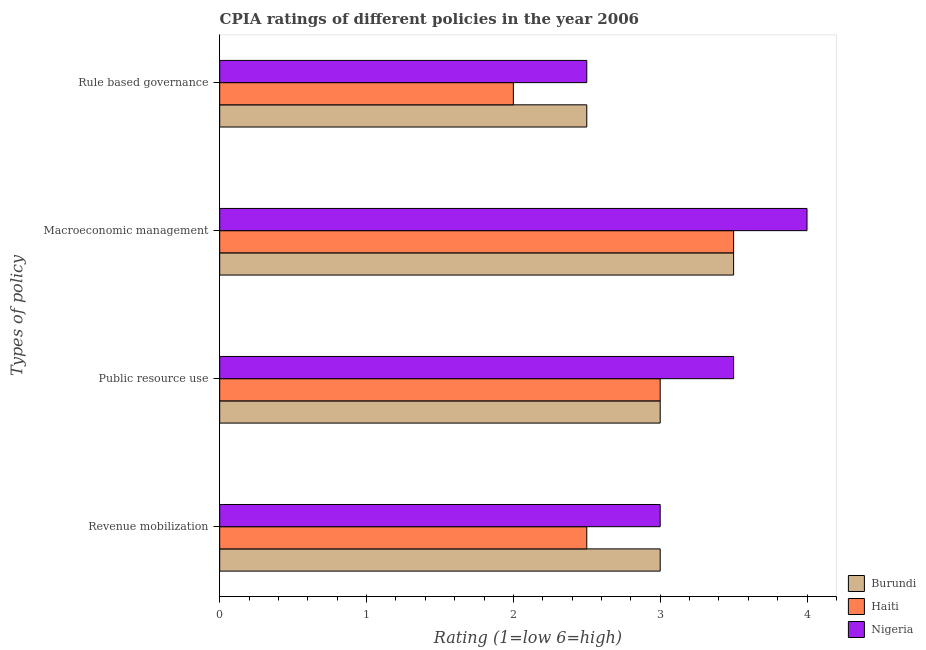How many groups of bars are there?
Provide a succinct answer. 4. How many bars are there on the 4th tick from the top?
Keep it short and to the point. 3. What is the label of the 4th group of bars from the top?
Your response must be concise. Revenue mobilization. Across all countries, what is the minimum cpia rating of macroeconomic management?
Keep it short and to the point. 3.5. In which country was the cpia rating of macroeconomic management maximum?
Offer a terse response. Nigeria. In which country was the cpia rating of macroeconomic management minimum?
Your answer should be compact. Burundi. What is the difference between the cpia rating of public resource use in Haiti and that in Burundi?
Your answer should be compact. 0. What is the difference between the cpia rating of rule based governance in Burundi and the cpia rating of public resource use in Nigeria?
Offer a very short reply. -1. What is the average cpia rating of macroeconomic management per country?
Offer a terse response. 3.67. In how many countries, is the cpia rating of rule based governance greater than 2.8 ?
Offer a terse response. 0. What is the ratio of the cpia rating of public resource use in Burundi to that in Haiti?
Your answer should be very brief. 1. Is the cpia rating of revenue mobilization in Burundi less than that in Nigeria?
Your response must be concise. No. What is the difference between the highest and the second highest cpia rating of public resource use?
Provide a short and direct response. 0.5. What is the difference between the highest and the lowest cpia rating of revenue mobilization?
Make the answer very short. 0.5. In how many countries, is the cpia rating of public resource use greater than the average cpia rating of public resource use taken over all countries?
Offer a terse response. 1. Is it the case that in every country, the sum of the cpia rating of public resource use and cpia rating of rule based governance is greater than the sum of cpia rating of macroeconomic management and cpia rating of revenue mobilization?
Keep it short and to the point. No. What does the 2nd bar from the top in Macroeconomic management represents?
Your answer should be compact. Haiti. What does the 3rd bar from the bottom in Macroeconomic management represents?
Provide a short and direct response. Nigeria. Is it the case that in every country, the sum of the cpia rating of revenue mobilization and cpia rating of public resource use is greater than the cpia rating of macroeconomic management?
Offer a terse response. Yes. Are all the bars in the graph horizontal?
Give a very brief answer. Yes. How many countries are there in the graph?
Provide a short and direct response. 3. Does the graph contain grids?
Your answer should be very brief. No. Where does the legend appear in the graph?
Ensure brevity in your answer.  Bottom right. How are the legend labels stacked?
Provide a short and direct response. Vertical. What is the title of the graph?
Keep it short and to the point. CPIA ratings of different policies in the year 2006. Does "Haiti" appear as one of the legend labels in the graph?
Make the answer very short. Yes. What is the label or title of the X-axis?
Your answer should be compact. Rating (1=low 6=high). What is the label or title of the Y-axis?
Keep it short and to the point. Types of policy. What is the Rating (1=low 6=high) in Burundi in Revenue mobilization?
Give a very brief answer. 3. What is the Rating (1=low 6=high) of Nigeria in Revenue mobilization?
Give a very brief answer. 3. What is the Rating (1=low 6=high) in Burundi in Public resource use?
Give a very brief answer. 3. What is the Rating (1=low 6=high) in Haiti in Public resource use?
Offer a terse response. 3. What is the Rating (1=low 6=high) in Haiti in Rule based governance?
Give a very brief answer. 2. What is the Rating (1=low 6=high) in Nigeria in Rule based governance?
Make the answer very short. 2.5. Across all Types of policy, what is the maximum Rating (1=low 6=high) of Burundi?
Keep it short and to the point. 3.5. Across all Types of policy, what is the maximum Rating (1=low 6=high) in Haiti?
Your answer should be compact. 3.5. Across all Types of policy, what is the maximum Rating (1=low 6=high) in Nigeria?
Your answer should be compact. 4. Across all Types of policy, what is the minimum Rating (1=low 6=high) in Haiti?
Your answer should be compact. 2. What is the total Rating (1=low 6=high) in Haiti in the graph?
Keep it short and to the point. 11. What is the difference between the Rating (1=low 6=high) in Nigeria in Revenue mobilization and that in Macroeconomic management?
Provide a short and direct response. -1. What is the difference between the Rating (1=low 6=high) in Haiti in Revenue mobilization and that in Rule based governance?
Provide a succinct answer. 0.5. What is the difference between the Rating (1=low 6=high) of Nigeria in Revenue mobilization and that in Rule based governance?
Offer a very short reply. 0.5. What is the difference between the Rating (1=low 6=high) of Haiti in Public resource use and that in Macroeconomic management?
Offer a very short reply. -0.5. What is the difference between the Rating (1=low 6=high) in Nigeria in Public resource use and that in Macroeconomic management?
Provide a succinct answer. -0.5. What is the difference between the Rating (1=low 6=high) in Burundi in Public resource use and that in Rule based governance?
Provide a short and direct response. 0.5. What is the difference between the Rating (1=low 6=high) of Nigeria in Public resource use and that in Rule based governance?
Give a very brief answer. 1. What is the difference between the Rating (1=low 6=high) in Haiti in Macroeconomic management and that in Rule based governance?
Offer a terse response. 1.5. What is the difference between the Rating (1=low 6=high) of Nigeria in Macroeconomic management and that in Rule based governance?
Your answer should be very brief. 1.5. What is the difference between the Rating (1=low 6=high) of Haiti in Revenue mobilization and the Rating (1=low 6=high) of Nigeria in Public resource use?
Your answer should be very brief. -1. What is the difference between the Rating (1=low 6=high) of Burundi in Revenue mobilization and the Rating (1=low 6=high) of Haiti in Macroeconomic management?
Keep it short and to the point. -0.5. What is the difference between the Rating (1=low 6=high) in Haiti in Revenue mobilization and the Rating (1=low 6=high) in Nigeria in Macroeconomic management?
Offer a very short reply. -1.5. What is the difference between the Rating (1=low 6=high) in Burundi in Revenue mobilization and the Rating (1=low 6=high) in Nigeria in Rule based governance?
Make the answer very short. 0.5. What is the difference between the Rating (1=low 6=high) of Burundi in Public resource use and the Rating (1=low 6=high) of Haiti in Macroeconomic management?
Offer a terse response. -0.5. What is the difference between the Rating (1=low 6=high) of Haiti in Public resource use and the Rating (1=low 6=high) of Nigeria in Macroeconomic management?
Make the answer very short. -1. What is the difference between the Rating (1=low 6=high) of Burundi in Public resource use and the Rating (1=low 6=high) of Nigeria in Rule based governance?
Offer a very short reply. 0.5. What is the difference between the Rating (1=low 6=high) in Haiti in Public resource use and the Rating (1=low 6=high) in Nigeria in Rule based governance?
Give a very brief answer. 0.5. What is the difference between the Rating (1=low 6=high) of Haiti in Macroeconomic management and the Rating (1=low 6=high) of Nigeria in Rule based governance?
Your answer should be very brief. 1. What is the average Rating (1=low 6=high) in Burundi per Types of policy?
Your answer should be compact. 3. What is the average Rating (1=low 6=high) in Haiti per Types of policy?
Your answer should be compact. 2.75. What is the difference between the Rating (1=low 6=high) in Burundi and Rating (1=low 6=high) in Nigeria in Revenue mobilization?
Keep it short and to the point. 0. What is the difference between the Rating (1=low 6=high) in Haiti and Rating (1=low 6=high) in Nigeria in Revenue mobilization?
Offer a terse response. -0.5. What is the difference between the Rating (1=low 6=high) of Haiti and Rating (1=low 6=high) of Nigeria in Public resource use?
Keep it short and to the point. -0.5. What is the difference between the Rating (1=low 6=high) of Burundi and Rating (1=low 6=high) of Nigeria in Macroeconomic management?
Keep it short and to the point. -0.5. What is the difference between the Rating (1=low 6=high) of Haiti and Rating (1=low 6=high) of Nigeria in Macroeconomic management?
Provide a succinct answer. -0.5. What is the difference between the Rating (1=low 6=high) in Burundi and Rating (1=low 6=high) in Haiti in Rule based governance?
Provide a short and direct response. 0.5. What is the difference between the Rating (1=low 6=high) of Burundi and Rating (1=low 6=high) of Nigeria in Rule based governance?
Offer a terse response. 0. What is the difference between the Rating (1=low 6=high) in Haiti and Rating (1=low 6=high) in Nigeria in Rule based governance?
Keep it short and to the point. -0.5. What is the ratio of the Rating (1=low 6=high) in Burundi in Revenue mobilization to that in Public resource use?
Keep it short and to the point. 1. What is the ratio of the Rating (1=low 6=high) of Haiti in Revenue mobilization to that in Public resource use?
Your answer should be compact. 0.83. What is the ratio of the Rating (1=low 6=high) in Nigeria in Revenue mobilization to that in Public resource use?
Make the answer very short. 0.86. What is the ratio of the Rating (1=low 6=high) in Burundi in Revenue mobilization to that in Macroeconomic management?
Your response must be concise. 0.86. What is the ratio of the Rating (1=low 6=high) in Nigeria in Revenue mobilization to that in Macroeconomic management?
Offer a very short reply. 0.75. What is the ratio of the Rating (1=low 6=high) of Haiti in Revenue mobilization to that in Rule based governance?
Keep it short and to the point. 1.25. What is the ratio of the Rating (1=low 6=high) of Nigeria in Revenue mobilization to that in Rule based governance?
Your answer should be compact. 1.2. What is the ratio of the Rating (1=low 6=high) in Haiti in Public resource use to that in Macroeconomic management?
Offer a terse response. 0.86. What is the ratio of the Rating (1=low 6=high) of Burundi in Public resource use to that in Rule based governance?
Give a very brief answer. 1.2. What is the ratio of the Rating (1=low 6=high) in Haiti in Public resource use to that in Rule based governance?
Offer a very short reply. 1.5. What is the ratio of the Rating (1=low 6=high) in Nigeria in Public resource use to that in Rule based governance?
Offer a terse response. 1.4. What is the ratio of the Rating (1=low 6=high) of Burundi in Macroeconomic management to that in Rule based governance?
Keep it short and to the point. 1.4. What is the ratio of the Rating (1=low 6=high) in Haiti in Macroeconomic management to that in Rule based governance?
Your answer should be compact. 1.75. What is the ratio of the Rating (1=low 6=high) of Nigeria in Macroeconomic management to that in Rule based governance?
Keep it short and to the point. 1.6. What is the difference between the highest and the second highest Rating (1=low 6=high) in Haiti?
Your answer should be very brief. 0.5. What is the difference between the highest and the second highest Rating (1=low 6=high) of Nigeria?
Offer a very short reply. 0.5. What is the difference between the highest and the lowest Rating (1=low 6=high) in Haiti?
Your answer should be very brief. 1.5. 